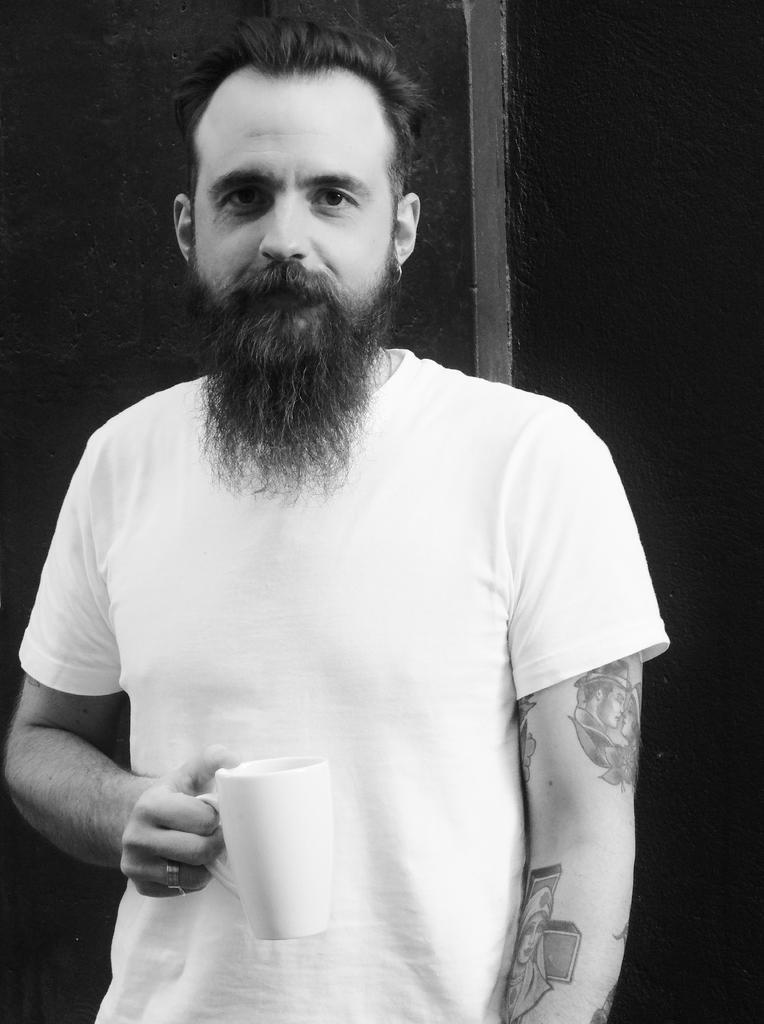Please provide a concise description of this image. English picture the person is visible and holding a cup and he is looking to the camera 